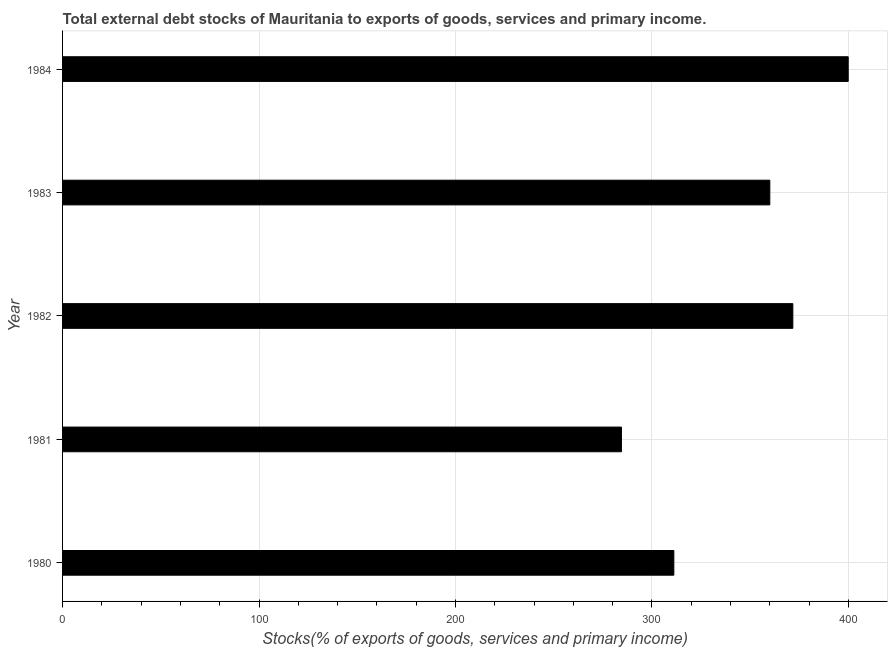Does the graph contain grids?
Offer a terse response. Yes. What is the title of the graph?
Make the answer very short. Total external debt stocks of Mauritania to exports of goods, services and primary income. What is the label or title of the X-axis?
Give a very brief answer. Stocks(% of exports of goods, services and primary income). What is the label or title of the Y-axis?
Your answer should be compact. Year. What is the external debt stocks in 1983?
Give a very brief answer. 360.05. Across all years, what is the maximum external debt stocks?
Keep it short and to the point. 399.96. Across all years, what is the minimum external debt stocks?
Your response must be concise. 284.52. In which year was the external debt stocks minimum?
Your response must be concise. 1981. What is the sum of the external debt stocks?
Ensure brevity in your answer.  1727.49. What is the difference between the external debt stocks in 1980 and 1984?
Make the answer very short. -88.77. What is the average external debt stocks per year?
Give a very brief answer. 345.5. What is the median external debt stocks?
Make the answer very short. 360.05. Do a majority of the years between 1982 and 1981 (inclusive) have external debt stocks greater than 280 %?
Provide a short and direct response. No. What is the ratio of the external debt stocks in 1981 to that in 1982?
Provide a short and direct response. 0.77. Is the difference between the external debt stocks in 1980 and 1982 greater than the difference between any two years?
Ensure brevity in your answer.  No. What is the difference between the highest and the second highest external debt stocks?
Ensure brevity in your answer.  28.19. Is the sum of the external debt stocks in 1980 and 1984 greater than the maximum external debt stocks across all years?
Offer a very short reply. Yes. What is the difference between the highest and the lowest external debt stocks?
Your answer should be very brief. 115.44. How many bars are there?
Make the answer very short. 5. Are all the bars in the graph horizontal?
Keep it short and to the point. Yes. How many years are there in the graph?
Provide a short and direct response. 5. What is the Stocks(% of exports of goods, services and primary income) of 1980?
Provide a succinct answer. 311.19. What is the Stocks(% of exports of goods, services and primary income) in 1981?
Ensure brevity in your answer.  284.52. What is the Stocks(% of exports of goods, services and primary income) of 1982?
Make the answer very short. 371.77. What is the Stocks(% of exports of goods, services and primary income) in 1983?
Make the answer very short. 360.05. What is the Stocks(% of exports of goods, services and primary income) of 1984?
Offer a terse response. 399.96. What is the difference between the Stocks(% of exports of goods, services and primary income) in 1980 and 1981?
Your response must be concise. 26.67. What is the difference between the Stocks(% of exports of goods, services and primary income) in 1980 and 1982?
Offer a very short reply. -60.58. What is the difference between the Stocks(% of exports of goods, services and primary income) in 1980 and 1983?
Provide a succinct answer. -48.86. What is the difference between the Stocks(% of exports of goods, services and primary income) in 1980 and 1984?
Your response must be concise. -88.77. What is the difference between the Stocks(% of exports of goods, services and primary income) in 1981 and 1982?
Keep it short and to the point. -87.26. What is the difference between the Stocks(% of exports of goods, services and primary income) in 1981 and 1983?
Provide a succinct answer. -75.53. What is the difference between the Stocks(% of exports of goods, services and primary income) in 1981 and 1984?
Give a very brief answer. -115.44. What is the difference between the Stocks(% of exports of goods, services and primary income) in 1982 and 1983?
Keep it short and to the point. 11.72. What is the difference between the Stocks(% of exports of goods, services and primary income) in 1982 and 1984?
Your answer should be very brief. -28.19. What is the difference between the Stocks(% of exports of goods, services and primary income) in 1983 and 1984?
Make the answer very short. -39.91. What is the ratio of the Stocks(% of exports of goods, services and primary income) in 1980 to that in 1981?
Your answer should be very brief. 1.09. What is the ratio of the Stocks(% of exports of goods, services and primary income) in 1980 to that in 1982?
Offer a very short reply. 0.84. What is the ratio of the Stocks(% of exports of goods, services and primary income) in 1980 to that in 1983?
Make the answer very short. 0.86. What is the ratio of the Stocks(% of exports of goods, services and primary income) in 1980 to that in 1984?
Give a very brief answer. 0.78. What is the ratio of the Stocks(% of exports of goods, services and primary income) in 1981 to that in 1982?
Make the answer very short. 0.77. What is the ratio of the Stocks(% of exports of goods, services and primary income) in 1981 to that in 1983?
Ensure brevity in your answer.  0.79. What is the ratio of the Stocks(% of exports of goods, services and primary income) in 1981 to that in 1984?
Your answer should be very brief. 0.71. What is the ratio of the Stocks(% of exports of goods, services and primary income) in 1982 to that in 1983?
Provide a short and direct response. 1.03. 